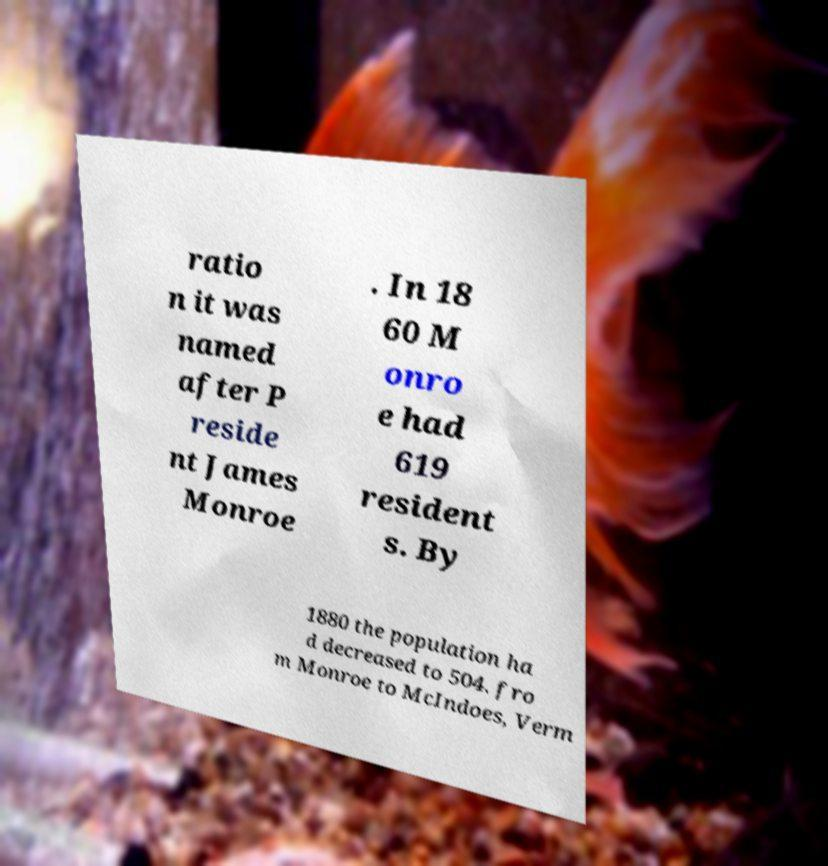Could you assist in decoding the text presented in this image and type it out clearly? ratio n it was named after P reside nt James Monroe . In 18 60 M onro e had 619 resident s. By 1880 the population ha d decreased to 504. fro m Monroe to McIndoes, Verm 